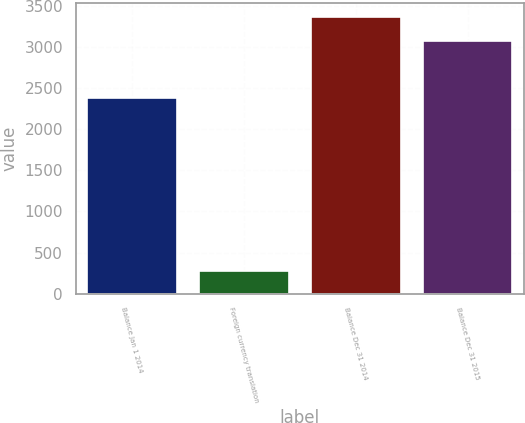Convert chart. <chart><loc_0><loc_0><loc_500><loc_500><bar_chart><fcel>Balance Jan 1 2014<fcel>Foreign currency translation<fcel>Balance Dec 31 2014<fcel>Balance Dec 31 2015<nl><fcel>2381<fcel>279<fcel>3371.8<fcel>3073<nl></chart> 